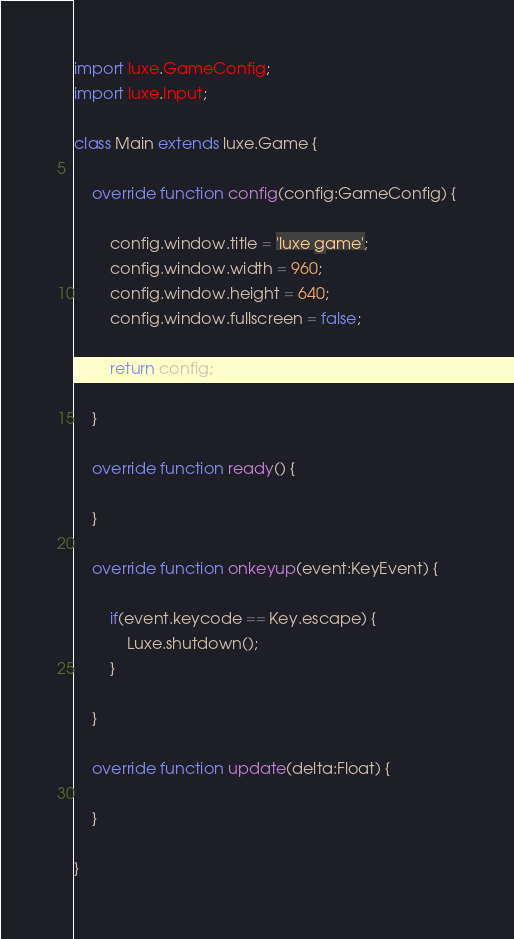Convert code to text. <code><loc_0><loc_0><loc_500><loc_500><_Haxe_>
import luxe.GameConfig;
import luxe.Input;

class Main extends luxe.Game {

    override function config(config:GameConfig) {

        config.window.title = 'luxe game';
        config.window.width = 960;
        config.window.height = 640;
        config.window.fullscreen = false;

        return config;

    }

    override function ready() {

    }

    override function onkeyup(event:KeyEvent) {

        if(event.keycode == Key.escape) {
            Luxe.shutdown();
        }

    }

    override function update(delta:Float) {

    }

}
</code> 